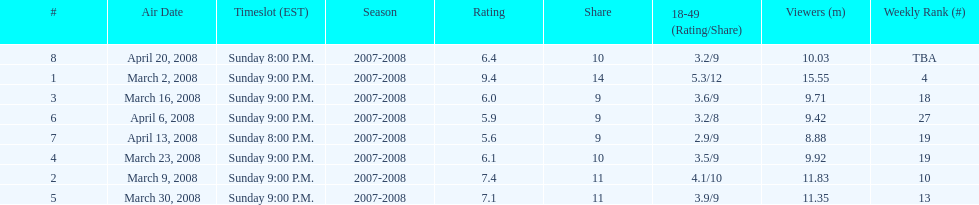How many shows had more than 10 million viewers? 4. 